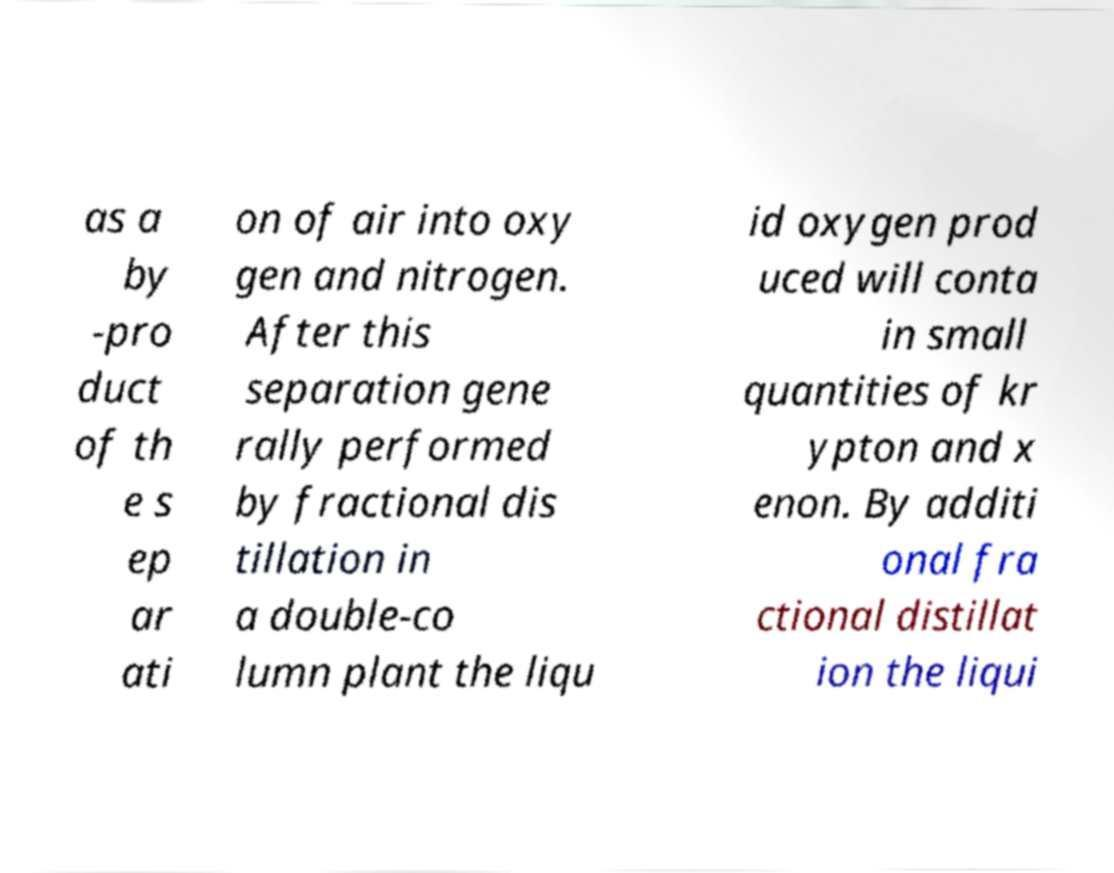Could you extract and type out the text from this image? as a by -pro duct of th e s ep ar ati on of air into oxy gen and nitrogen. After this separation gene rally performed by fractional dis tillation in a double-co lumn plant the liqu id oxygen prod uced will conta in small quantities of kr ypton and x enon. By additi onal fra ctional distillat ion the liqui 